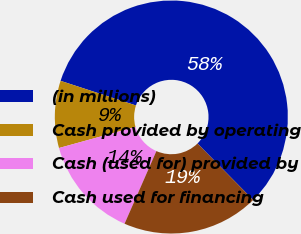Convert chart to OTSL. <chart><loc_0><loc_0><loc_500><loc_500><pie_chart><fcel>(in millions)<fcel>Cash provided by operating<fcel>Cash (used for) provided by<fcel>Cash used for financing<nl><fcel>57.58%<fcel>9.31%<fcel>14.14%<fcel>18.97%<nl></chart> 